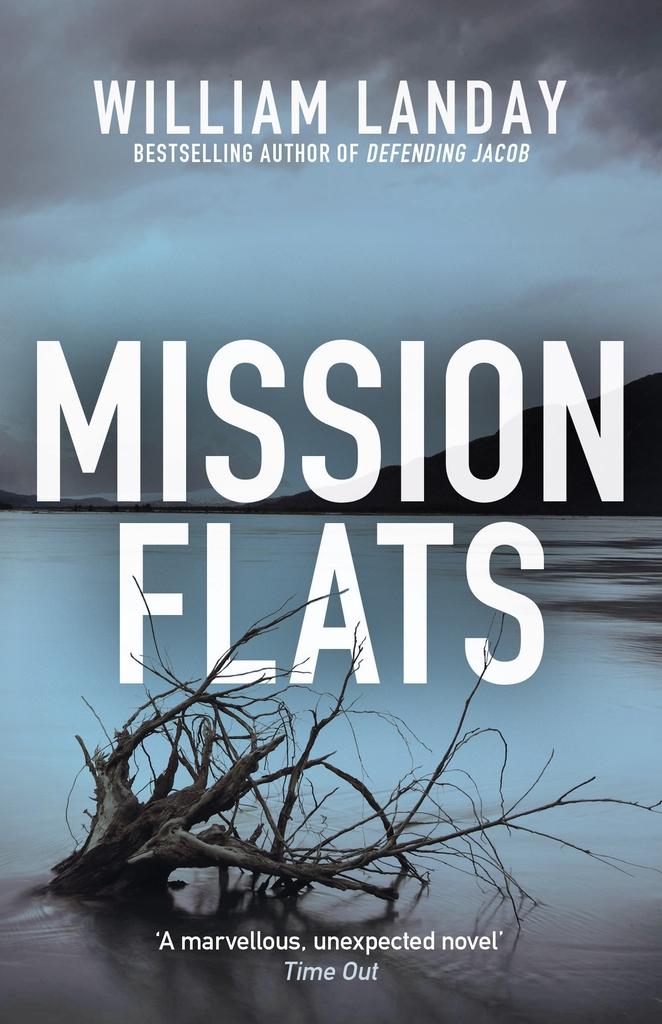What did time out say about this novel?
Offer a very short reply. A marvellous, unexpected novel. Who wrote this?
Make the answer very short. William landay. 